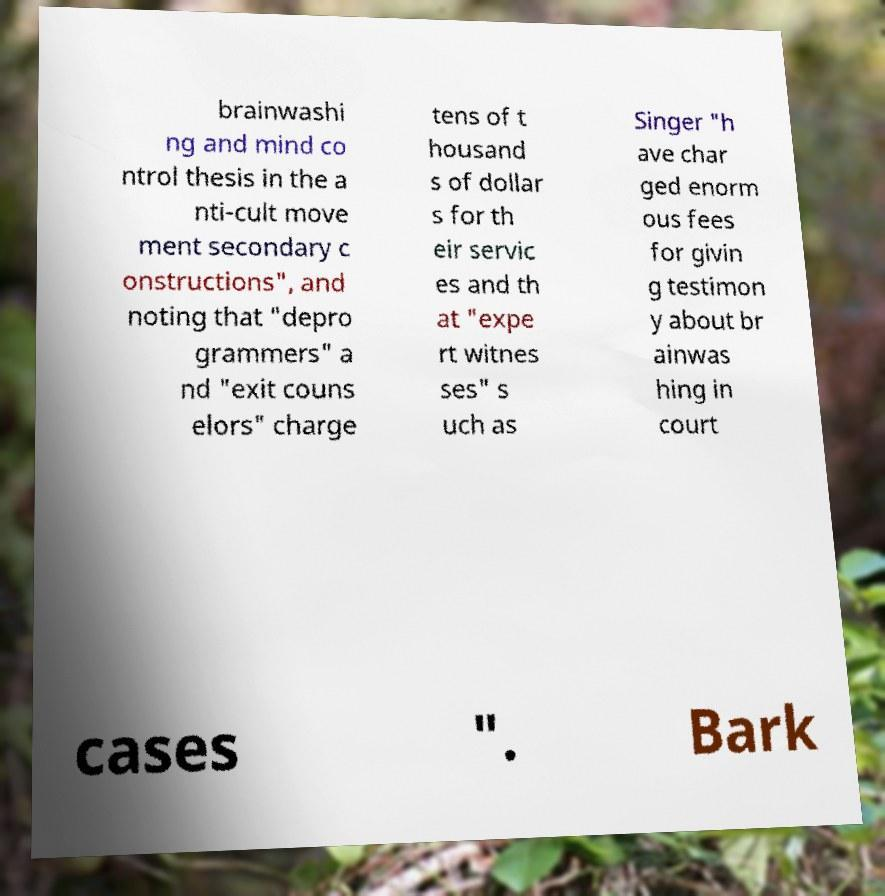For documentation purposes, I need the text within this image transcribed. Could you provide that? brainwashi ng and mind co ntrol thesis in the a nti-cult move ment secondary c onstructions", and noting that "depro grammers" a nd "exit couns elors" charge tens of t housand s of dollar s for th eir servic es and th at "expe rt witnes ses" s uch as Singer "h ave char ged enorm ous fees for givin g testimon y about br ainwas hing in court cases ". Bark 